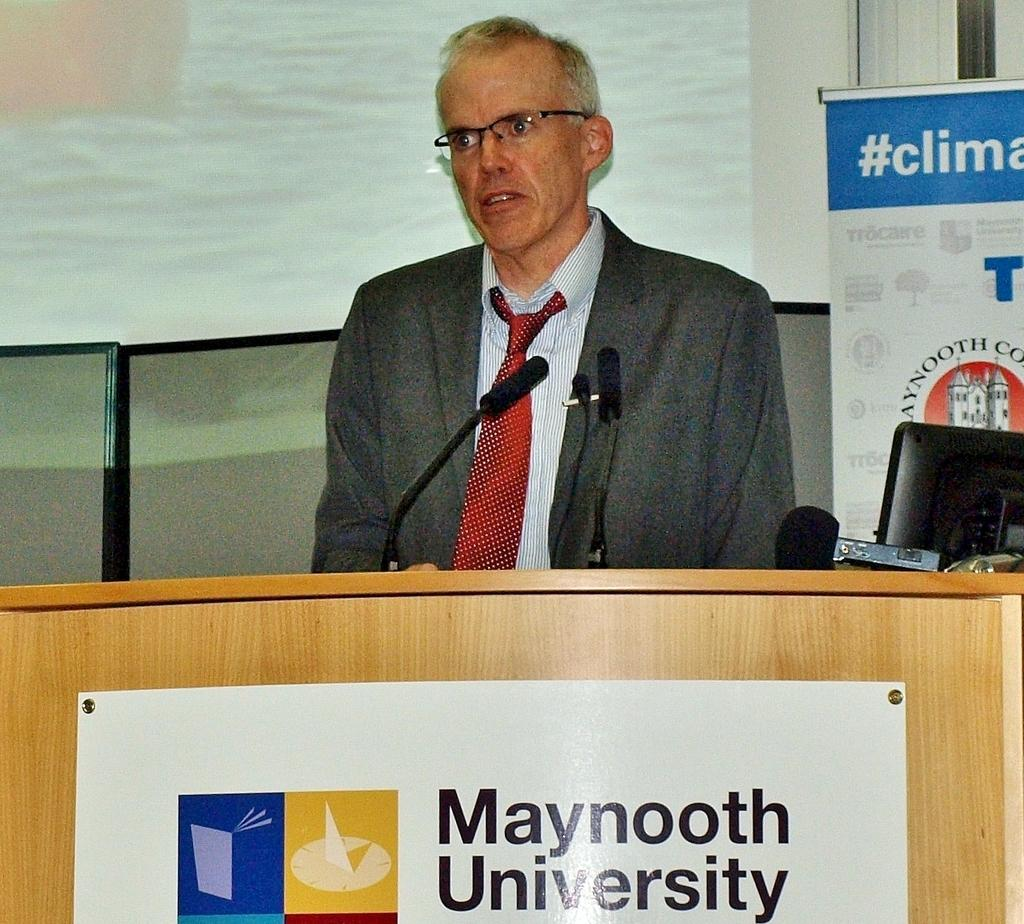<image>
Present a compact description of the photo's key features. A man is standing at a podium at Maynooth University. 